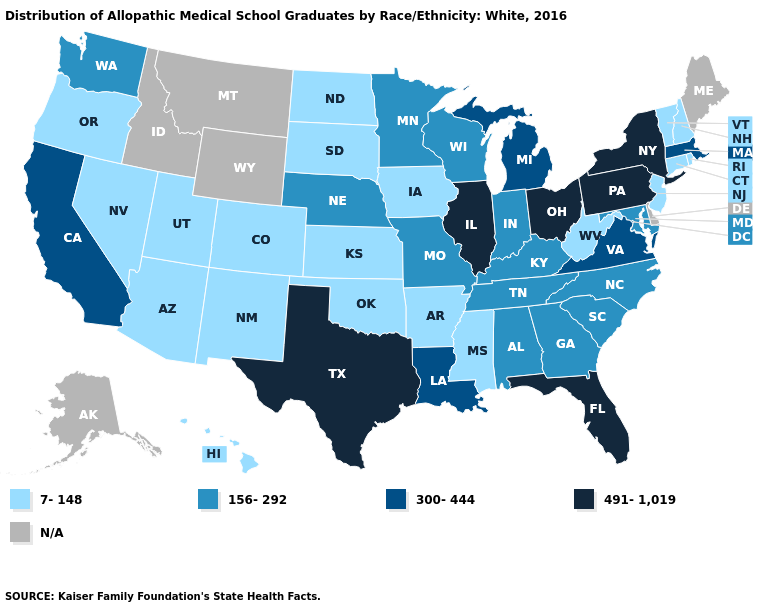Does the first symbol in the legend represent the smallest category?
Answer briefly. Yes. Name the states that have a value in the range N/A?
Keep it brief. Alaska, Delaware, Idaho, Maine, Montana, Wyoming. Among the states that border New Mexico , does Texas have the lowest value?
Short answer required. No. What is the highest value in the Northeast ?
Quick response, please. 491-1,019. What is the lowest value in states that border Iowa?
Short answer required. 7-148. Name the states that have a value in the range 7-148?
Be succinct. Arizona, Arkansas, Colorado, Connecticut, Hawaii, Iowa, Kansas, Mississippi, Nevada, New Hampshire, New Jersey, New Mexico, North Dakota, Oklahoma, Oregon, Rhode Island, South Dakota, Utah, Vermont, West Virginia. Name the states that have a value in the range 156-292?
Give a very brief answer. Alabama, Georgia, Indiana, Kentucky, Maryland, Minnesota, Missouri, Nebraska, North Carolina, South Carolina, Tennessee, Washington, Wisconsin. Among the states that border Washington , which have the lowest value?
Quick response, please. Oregon. Name the states that have a value in the range 156-292?
Write a very short answer. Alabama, Georgia, Indiana, Kentucky, Maryland, Minnesota, Missouri, Nebraska, North Carolina, South Carolina, Tennessee, Washington, Wisconsin. What is the value of Mississippi?
Answer briefly. 7-148. Does the first symbol in the legend represent the smallest category?
Short answer required. Yes. Does the map have missing data?
Short answer required. Yes. Does California have the highest value in the West?
Concise answer only. Yes. 